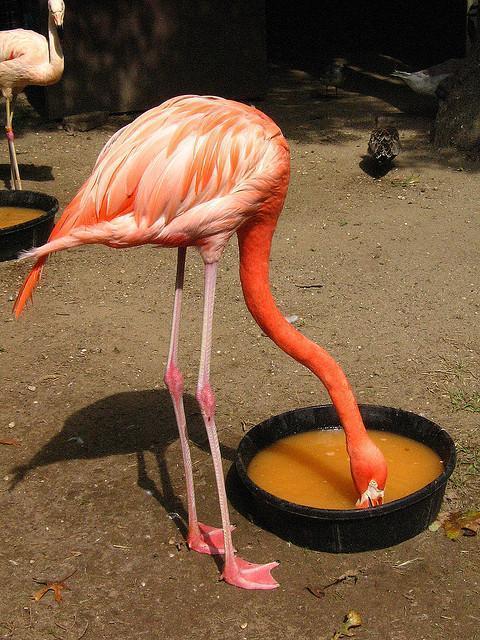How many flamingos are here?
Give a very brief answer. 2. How many birds are there?
Give a very brief answer. 2. How many bowls can you see?
Give a very brief answer. 2. How many people are wearing glasses?
Give a very brief answer. 0. 